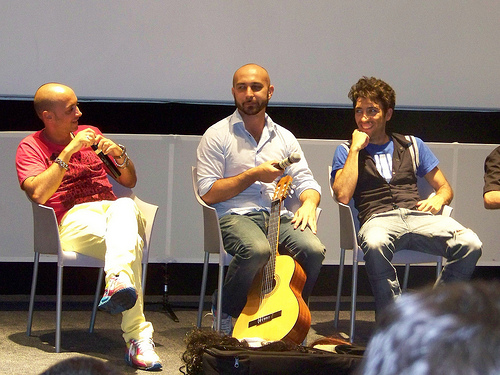<image>
Is there a shirt on the man? No. The shirt is not positioned on the man. They may be near each other, but the shirt is not supported by or resting on top of the man. Is the guitar under the man? Yes. The guitar is positioned underneath the man, with the man above it in the vertical space. 